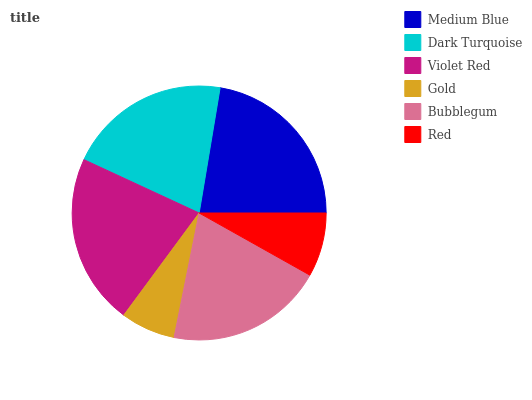Is Gold the minimum?
Answer yes or no. Yes. Is Medium Blue the maximum?
Answer yes or no. Yes. Is Dark Turquoise the minimum?
Answer yes or no. No. Is Dark Turquoise the maximum?
Answer yes or no. No. Is Medium Blue greater than Dark Turquoise?
Answer yes or no. Yes. Is Dark Turquoise less than Medium Blue?
Answer yes or no. Yes. Is Dark Turquoise greater than Medium Blue?
Answer yes or no. No. Is Medium Blue less than Dark Turquoise?
Answer yes or no. No. Is Dark Turquoise the high median?
Answer yes or no. Yes. Is Bubblegum the low median?
Answer yes or no. Yes. Is Bubblegum the high median?
Answer yes or no. No. Is Red the low median?
Answer yes or no. No. 